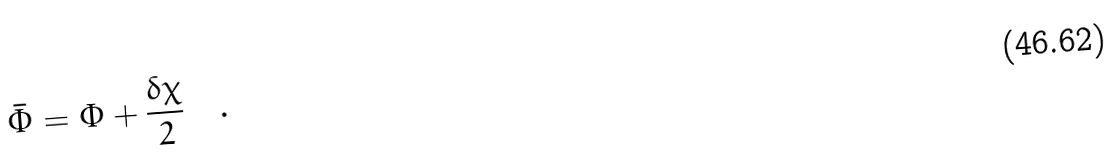<formula> <loc_0><loc_0><loc_500><loc_500>\bar { \Phi } = \Phi + \frac { \delta \chi } { 2 } \quad .</formula> 